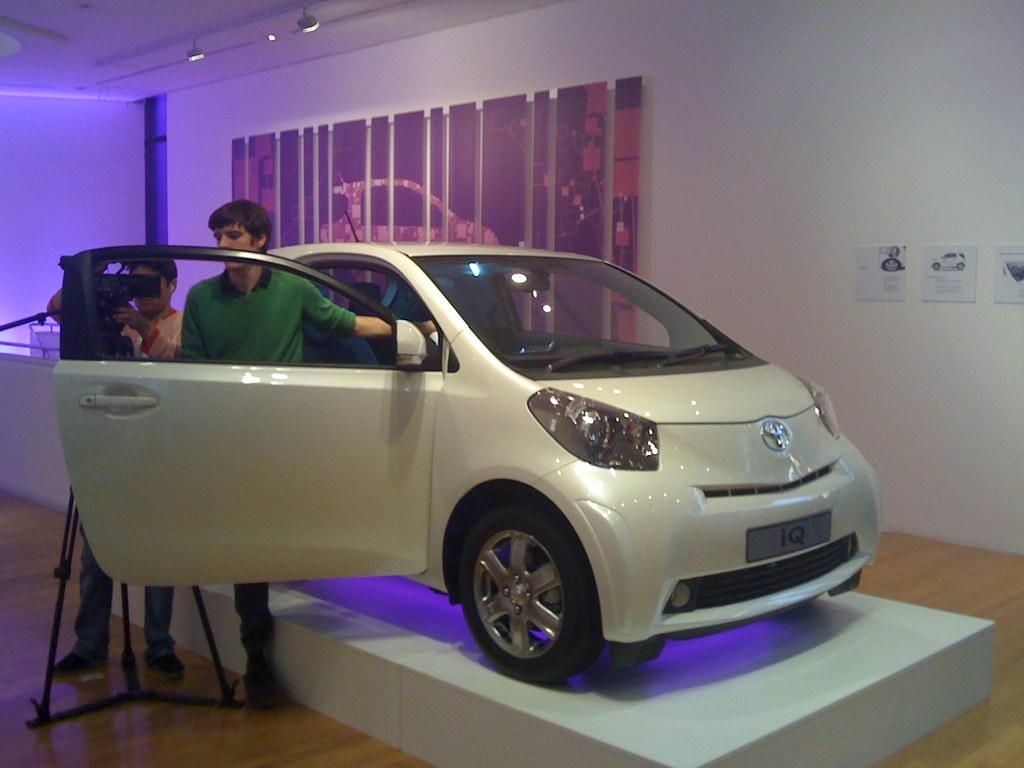How many people are in the image? There are two men standing in the image. What object is present for capturing images? There is a camera with a stand in the image. What type of vehicle can be seen in the background? A car is visible on the surface in the background. What architectural features are present in the background? There are posts on a wall in the background. What type of illumination is present in the background? There are lights in the background. What type of vegetable is being used as a prop by one of the men in the image? There is no vegetable present in the image; it features two men, a camera with a stand, a car, posts, and lights. 